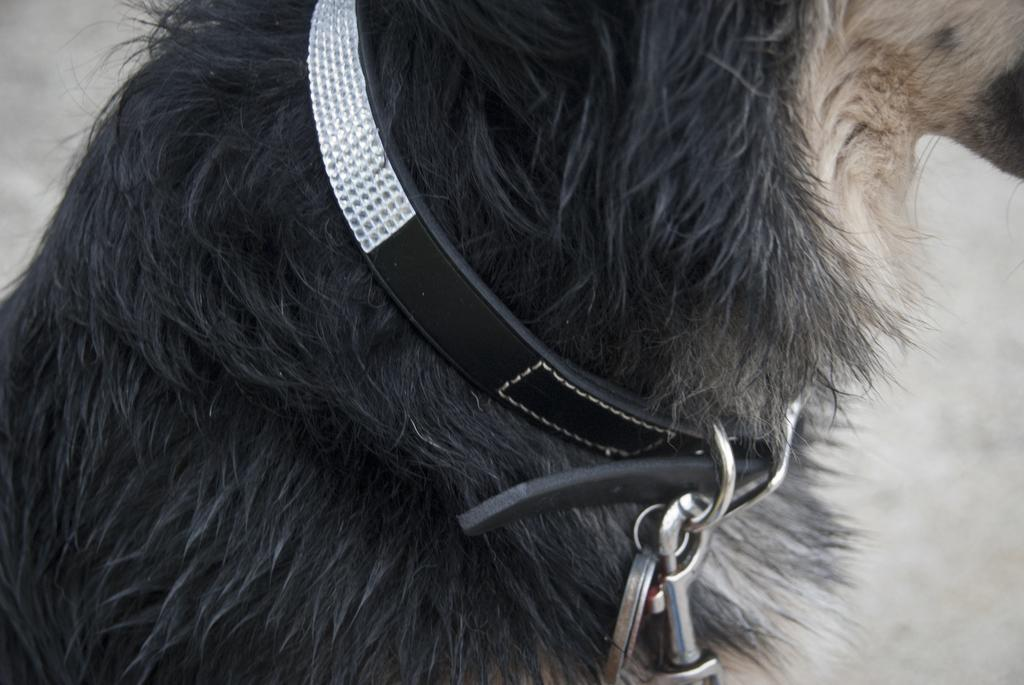What type of animal is in the image? There is a black color animal in the image. Can you describe any unique features of the animal? The animal is wearing a belt. What color is the object in the background of the image? There is a white color object in the background of the image. How many apples are being held by the babies in the image? There are no babies or apples present in the image. Are the friends in the image playing a game together? There is no mention of friends or a game in the image. 